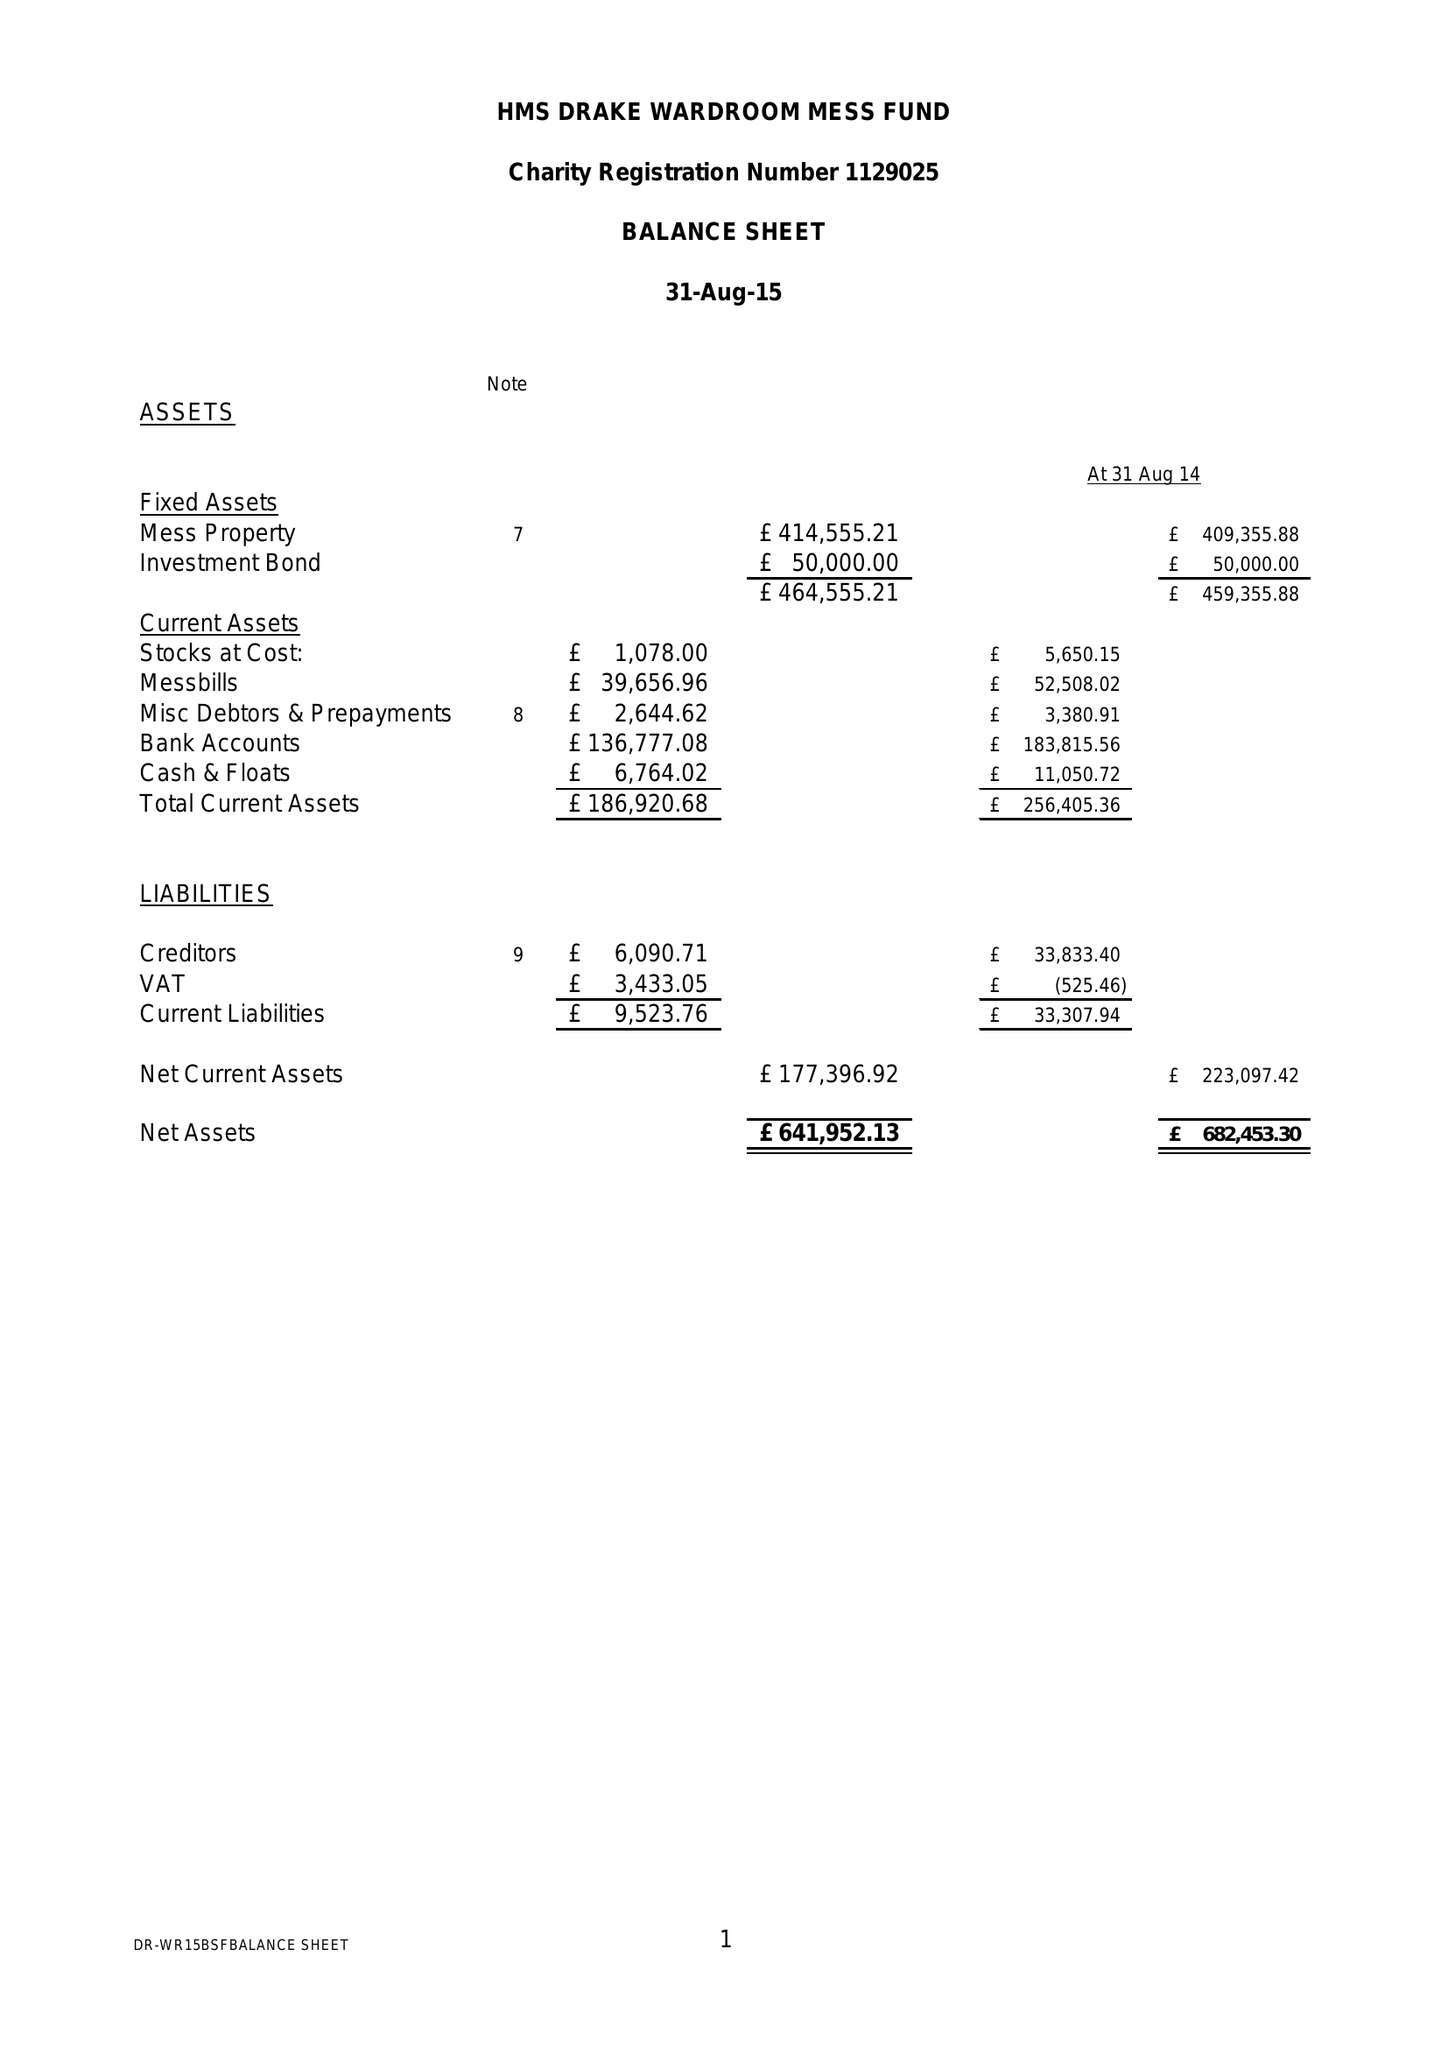What is the value for the address__postcode?
Answer the question using a single word or phrase. PL2 2BG 